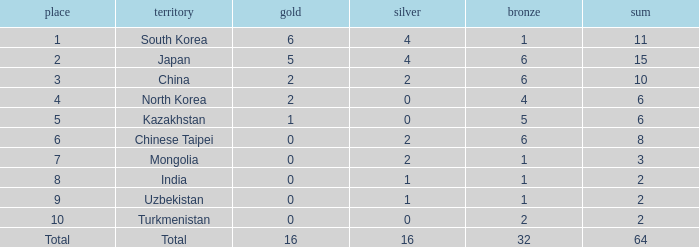What's the biggest Bronze that has less than 0 Silvers? None. 